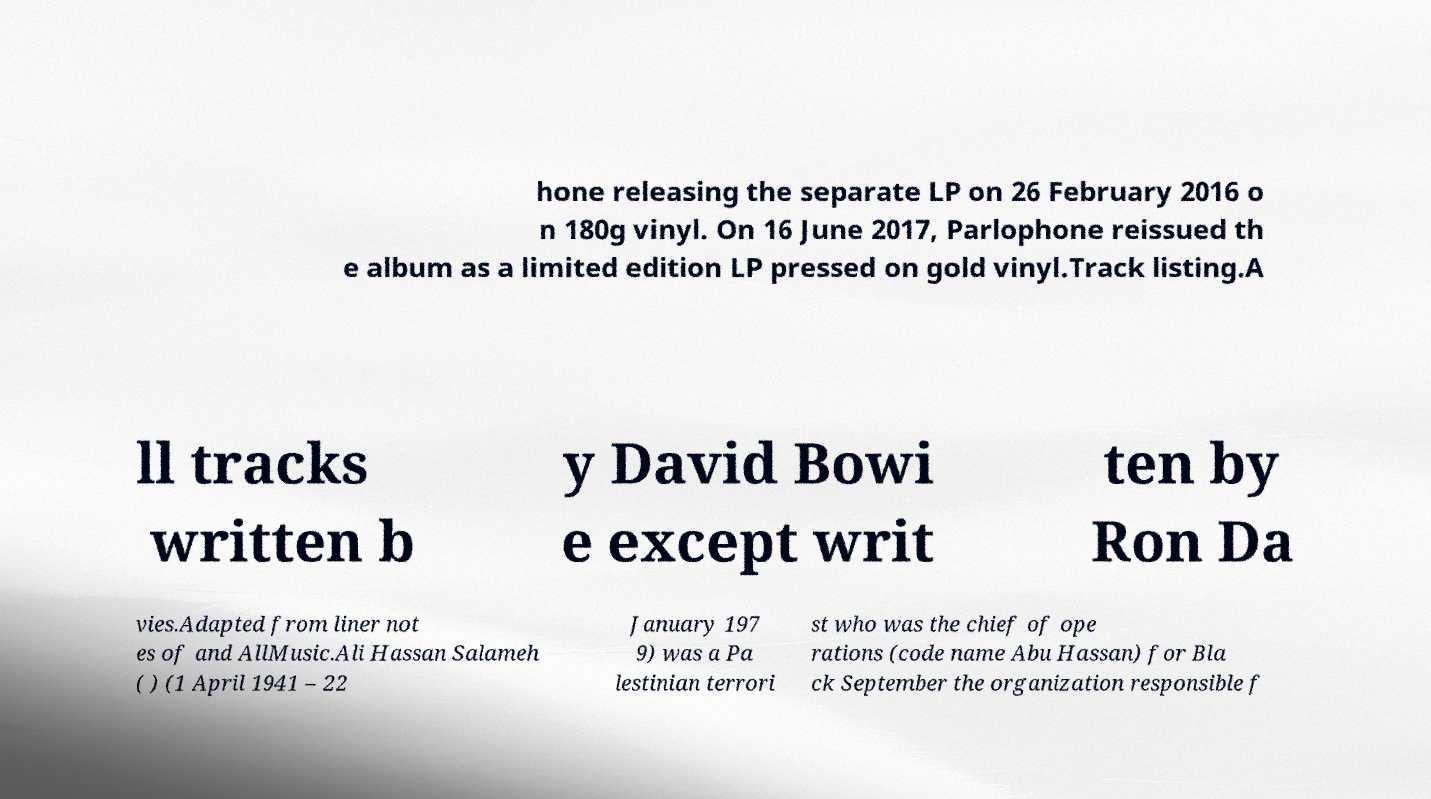Can you accurately transcribe the text from the provided image for me? hone releasing the separate LP on 26 February 2016 o n 180g vinyl. On 16 June 2017, Parlophone reissued th e album as a limited edition LP pressed on gold vinyl.Track listing.A ll tracks written b y David Bowi e except writ ten by Ron Da vies.Adapted from liner not es of and AllMusic.Ali Hassan Salameh ( ) (1 April 1941 – 22 January 197 9) was a Pa lestinian terrori st who was the chief of ope rations (code name Abu Hassan) for Bla ck September the organization responsible f 